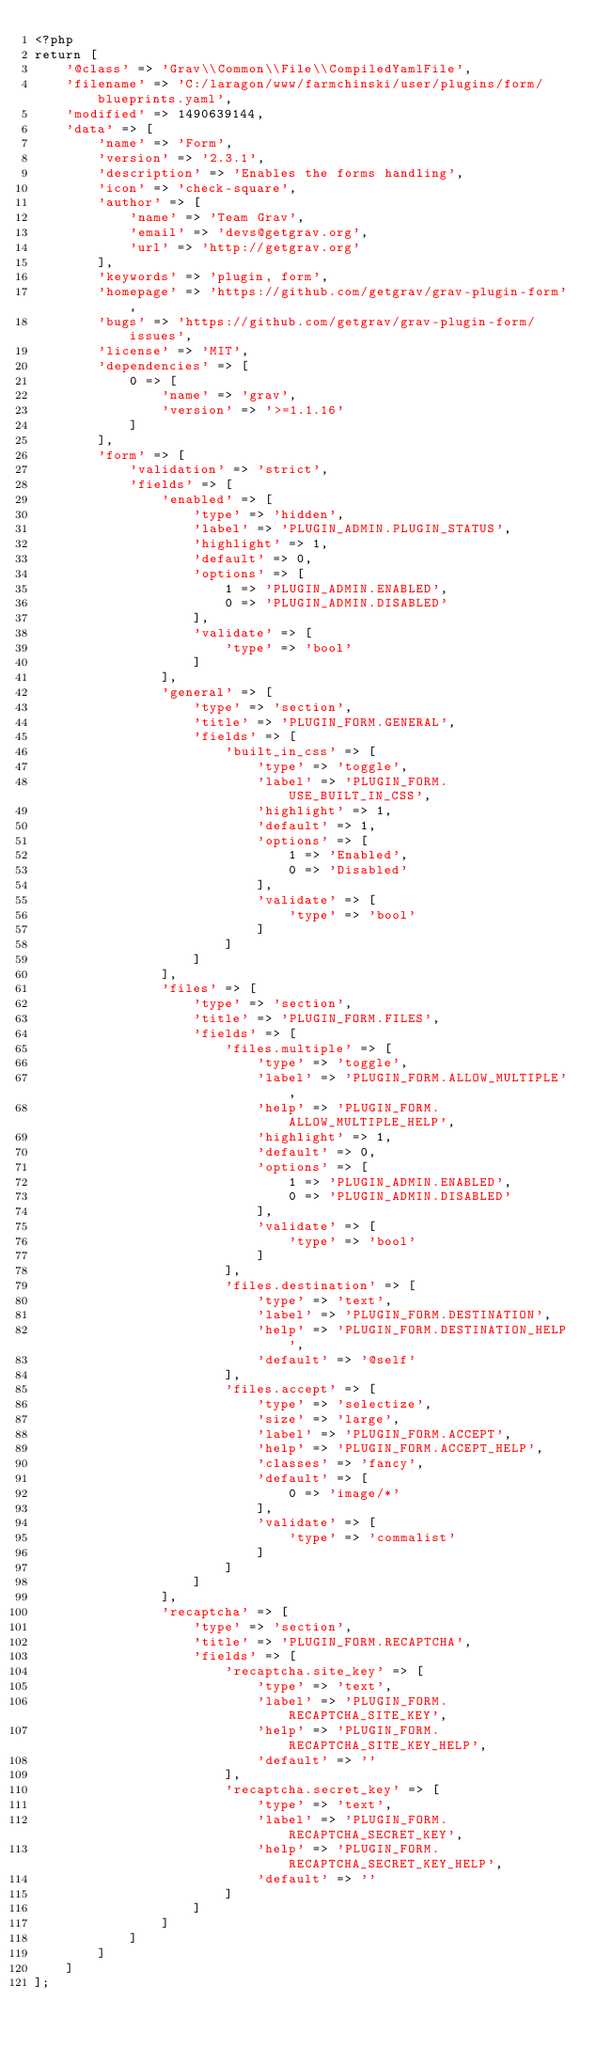<code> <loc_0><loc_0><loc_500><loc_500><_PHP_><?php
return [
    '@class' => 'Grav\\Common\\File\\CompiledYamlFile',
    'filename' => 'C:/laragon/www/farmchinski/user/plugins/form/blueprints.yaml',
    'modified' => 1490639144,
    'data' => [
        'name' => 'Form',
        'version' => '2.3.1',
        'description' => 'Enables the forms handling',
        'icon' => 'check-square',
        'author' => [
            'name' => 'Team Grav',
            'email' => 'devs@getgrav.org',
            'url' => 'http://getgrav.org'
        ],
        'keywords' => 'plugin, form',
        'homepage' => 'https://github.com/getgrav/grav-plugin-form',
        'bugs' => 'https://github.com/getgrav/grav-plugin-form/issues',
        'license' => 'MIT',
        'dependencies' => [
            0 => [
                'name' => 'grav',
                'version' => '>=1.1.16'
            ]
        ],
        'form' => [
            'validation' => 'strict',
            'fields' => [
                'enabled' => [
                    'type' => 'hidden',
                    'label' => 'PLUGIN_ADMIN.PLUGIN_STATUS',
                    'highlight' => 1,
                    'default' => 0,
                    'options' => [
                        1 => 'PLUGIN_ADMIN.ENABLED',
                        0 => 'PLUGIN_ADMIN.DISABLED'
                    ],
                    'validate' => [
                        'type' => 'bool'
                    ]
                ],
                'general' => [
                    'type' => 'section',
                    'title' => 'PLUGIN_FORM.GENERAL',
                    'fields' => [
                        'built_in_css' => [
                            'type' => 'toggle',
                            'label' => 'PLUGIN_FORM.USE_BUILT_IN_CSS',
                            'highlight' => 1,
                            'default' => 1,
                            'options' => [
                                1 => 'Enabled',
                                0 => 'Disabled'
                            ],
                            'validate' => [
                                'type' => 'bool'
                            ]
                        ]
                    ]
                ],
                'files' => [
                    'type' => 'section',
                    'title' => 'PLUGIN_FORM.FILES',
                    'fields' => [
                        'files.multiple' => [
                            'type' => 'toggle',
                            'label' => 'PLUGIN_FORM.ALLOW_MULTIPLE',
                            'help' => 'PLUGIN_FORM.ALLOW_MULTIPLE_HELP',
                            'highlight' => 1,
                            'default' => 0,
                            'options' => [
                                1 => 'PLUGIN_ADMIN.ENABLED',
                                0 => 'PLUGIN_ADMIN.DISABLED'
                            ],
                            'validate' => [
                                'type' => 'bool'
                            ]
                        ],
                        'files.destination' => [
                            'type' => 'text',
                            'label' => 'PLUGIN_FORM.DESTINATION',
                            'help' => 'PLUGIN_FORM.DESTINATION_HELP',
                            'default' => '@self'
                        ],
                        'files.accept' => [
                            'type' => 'selectize',
                            'size' => 'large',
                            'label' => 'PLUGIN_FORM.ACCEPT',
                            'help' => 'PLUGIN_FORM.ACCEPT_HELP',
                            'classes' => 'fancy',
                            'default' => [
                                0 => 'image/*'
                            ],
                            'validate' => [
                                'type' => 'commalist'
                            ]
                        ]
                    ]
                ],
                'recaptcha' => [
                    'type' => 'section',
                    'title' => 'PLUGIN_FORM.RECAPTCHA',
                    'fields' => [
                        'recaptcha.site_key' => [
                            'type' => 'text',
                            'label' => 'PLUGIN_FORM.RECAPTCHA_SITE_KEY',
                            'help' => 'PLUGIN_FORM.RECAPTCHA_SITE_KEY_HELP',
                            'default' => ''
                        ],
                        'recaptcha.secret_key' => [
                            'type' => 'text',
                            'label' => 'PLUGIN_FORM.RECAPTCHA_SECRET_KEY',
                            'help' => 'PLUGIN_FORM.RECAPTCHA_SECRET_KEY_HELP',
                            'default' => ''
                        ]
                    ]
                ]
            ]
        ]
    ]
];
</code> 